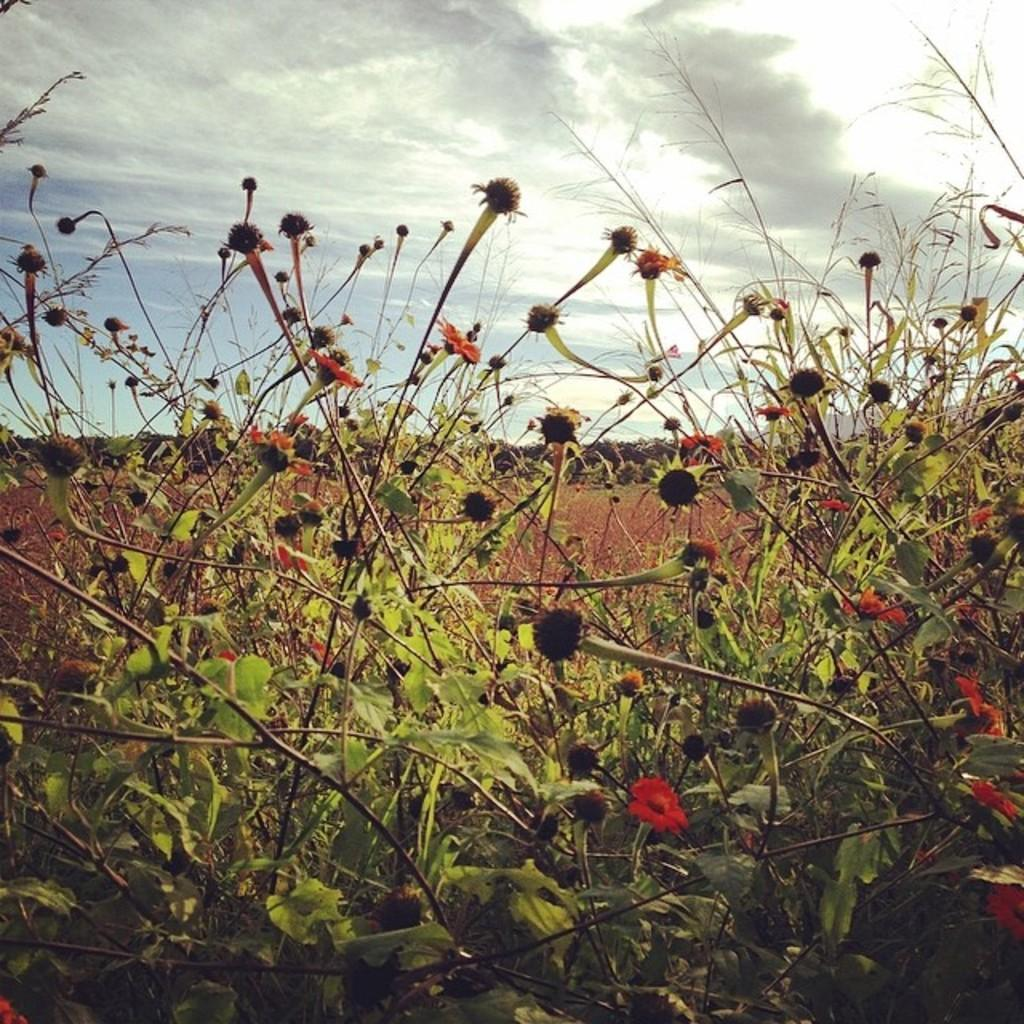What type of living organisms can be seen in the image? Plants can be seen in the image, and they have flowers associated with them. What can be seen in the sky in the image? Clouds are visible in the sky in the image. What type of discussion is happening between the monkeys in the image? There are no monkeys present in the image, so there cannot be a discussion between them. 